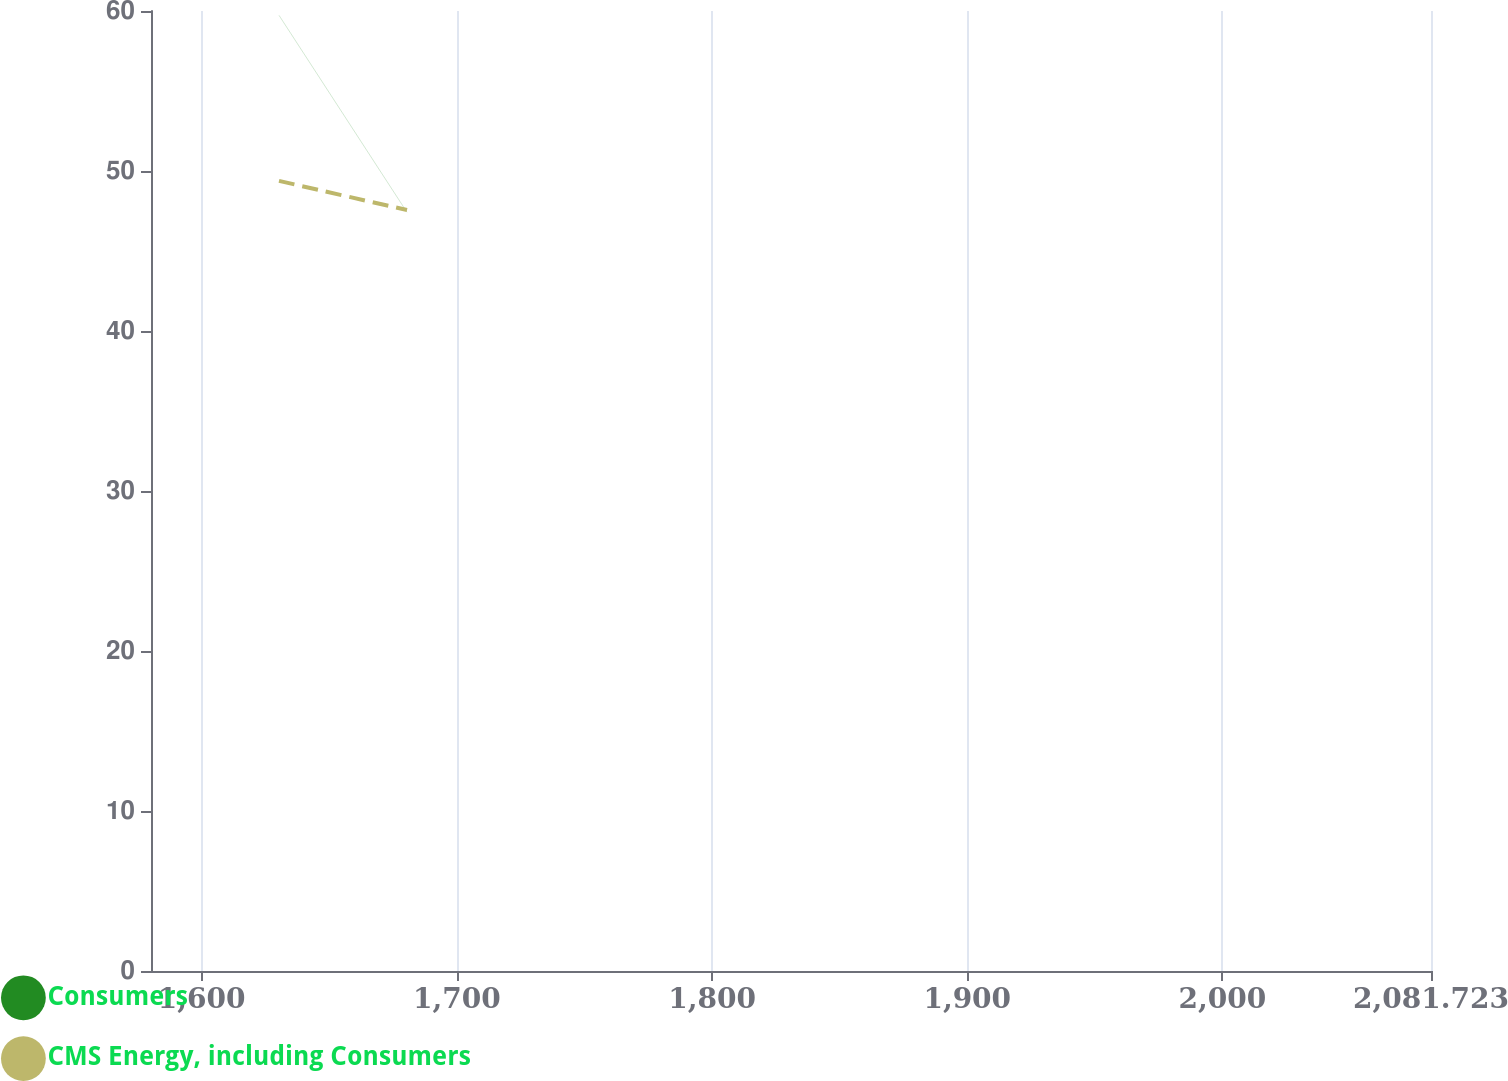Convert chart. <chart><loc_0><loc_0><loc_500><loc_500><line_chart><ecel><fcel>Consumers<fcel>CMS Energy, including Consumers<nl><fcel>1630.31<fcel>59.73<fcel>49.38<nl><fcel>1680.47<fcel>47.42<fcel>47.56<nl><fcel>2131.88<fcel>43.51<fcel>30.78<nl></chart> 